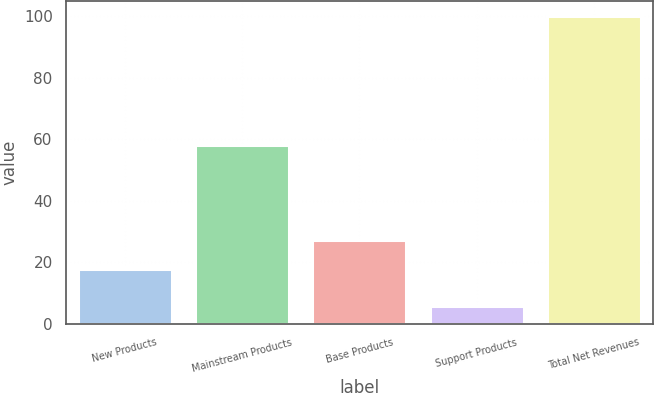Convert chart to OTSL. <chart><loc_0><loc_0><loc_500><loc_500><bar_chart><fcel>New Products<fcel>Mainstream Products<fcel>Base Products<fcel>Support Products<fcel>Total Net Revenues<nl><fcel>18<fcel>58<fcel>27.4<fcel>6<fcel>100<nl></chart> 